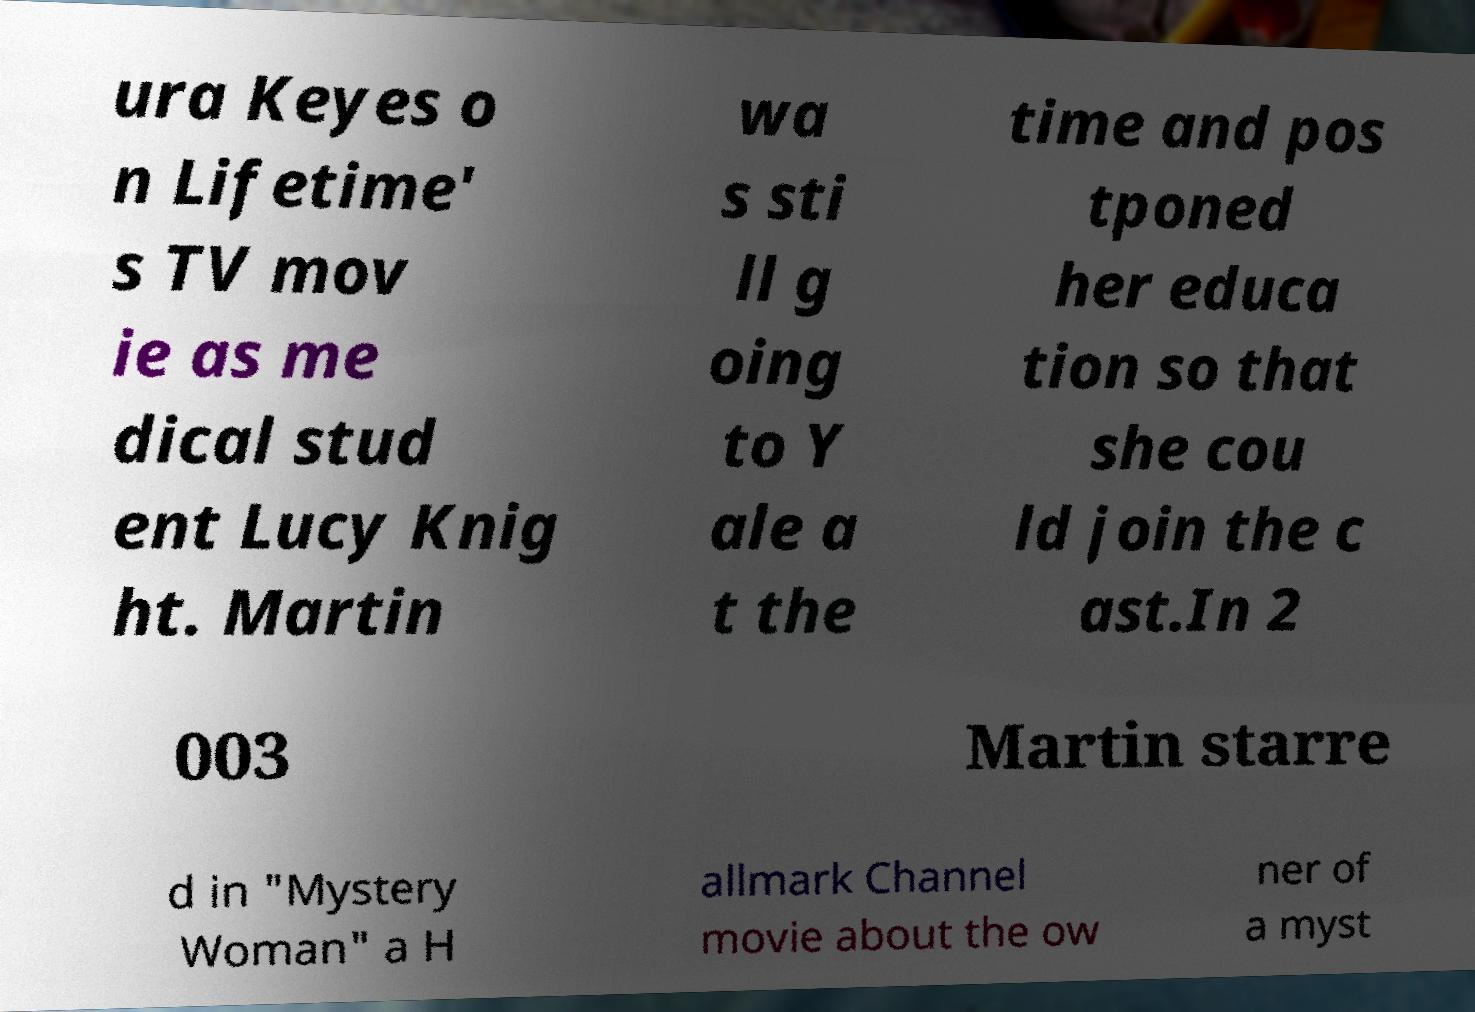Please identify and transcribe the text found in this image. ura Keyes o n Lifetime' s TV mov ie as me dical stud ent Lucy Knig ht. Martin wa s sti ll g oing to Y ale a t the time and pos tponed her educa tion so that she cou ld join the c ast.In 2 003 Martin starre d in "Mystery Woman" a H allmark Channel movie about the ow ner of a myst 